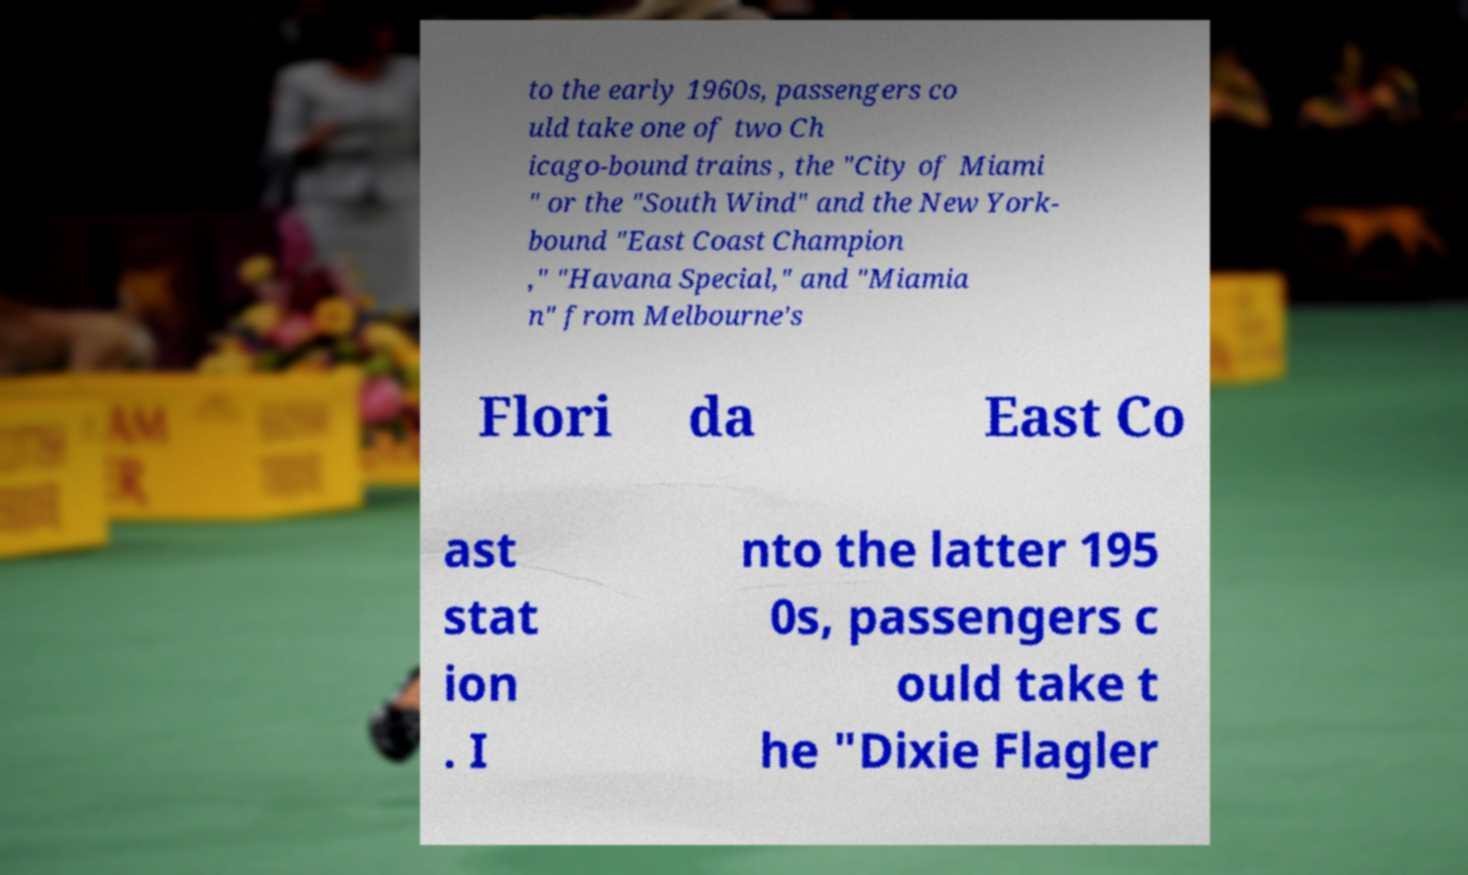There's text embedded in this image that I need extracted. Can you transcribe it verbatim? to the early 1960s, passengers co uld take one of two Ch icago-bound trains , the "City of Miami " or the "South Wind" and the New York- bound "East Coast Champion ," "Havana Special," and "Miamia n" from Melbourne's Flori da East Co ast stat ion . I nto the latter 195 0s, passengers c ould take t he "Dixie Flagler 